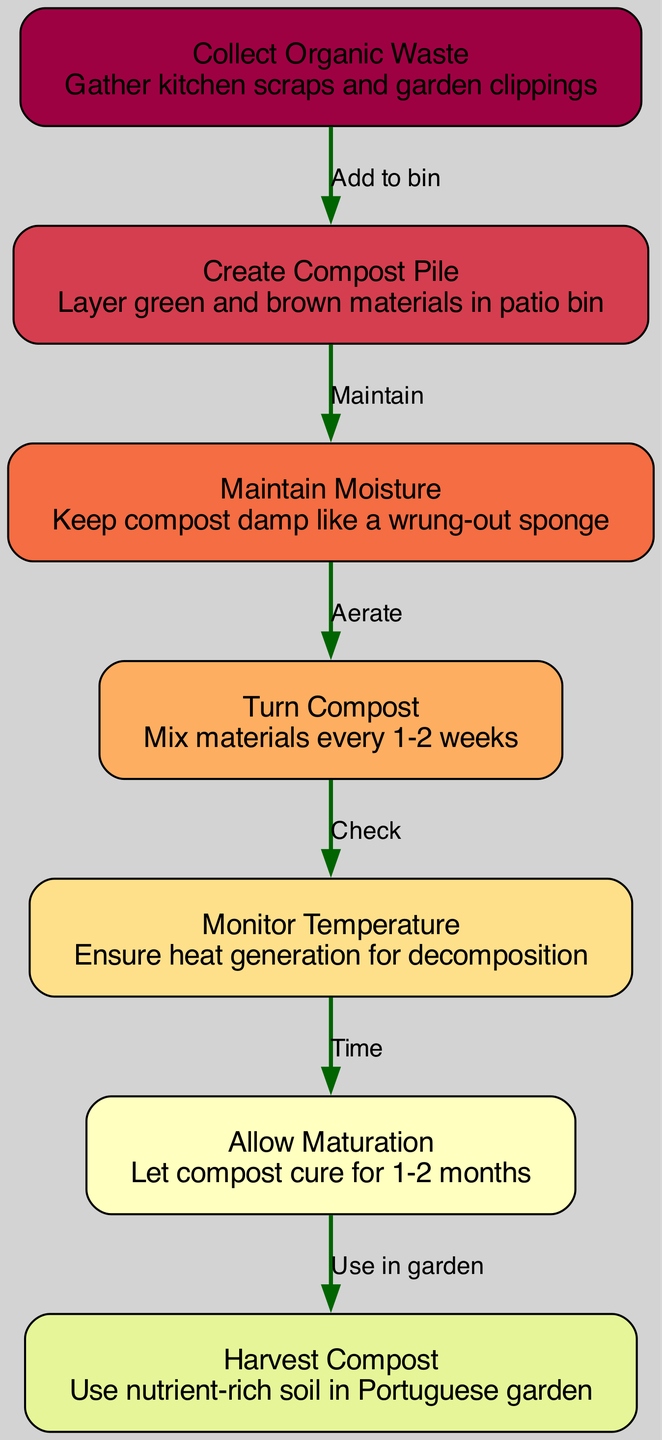What is the first step in the composting process? The first step is to "Collect Organic Waste," which involves gathering kitchen scraps and garden clippings. This is indicated by the first node in the diagram.
Answer: Collect Organic Waste How many nodes are present in the diagram? There are a total of 7 nodes in the diagram, as indicated by the number of unique steps in the composting process listed.
Answer: 7 What is the relationship between "Create Compost Pile" and "Maintain Moisture"? The relationship is that after "Create Compost Pile," the next action is to "Maintain Moisture," meaning you must manage moisture after building the compost to support decomposition. The arrow between these two nodes illustrates this connection.
Answer: Maintain What is the final step represented in the diagram? The final step is "Harvest Compost," where nutrient-rich soil is used in the garden, clearly indicated by the last node in the flow.
Answer: Harvest Compost How many edges are in the diagram? The diagram contains 6 edges that represent the connections and flow between the 7 nodes. This can be counted based on how many arrows connect the nodes.
Answer: 6 Which step follows "Turn Compost"? "Monitor Temperature" follows "Turn Compost." This means after turning the compost, the next action is to check the temperature to ensure proper conditions for decomposition.
Answer: Monitor Temperature What action is required to keep the compost moist? The action required is to "Maintain Moisture," which means the compost should be kept damp, akin to a wrung-out sponge. This is detailed in the description of the respective node.
Answer: Maintain Moisture What is the duration for allowing maturation of the compost? The duration for allowing maturation is "1-2 months," as indicated in the description of the "Allow Maturation" step in the composting process.
Answer: 1-2 months What is the significance of "Monitor Temperature" in the process? "Monitor Temperature" is significant because it ensures heat generation for decomposition. This step emphasizes the importance of temperature control in the composting process, as indicated in its description.
Answer: Heat generation 